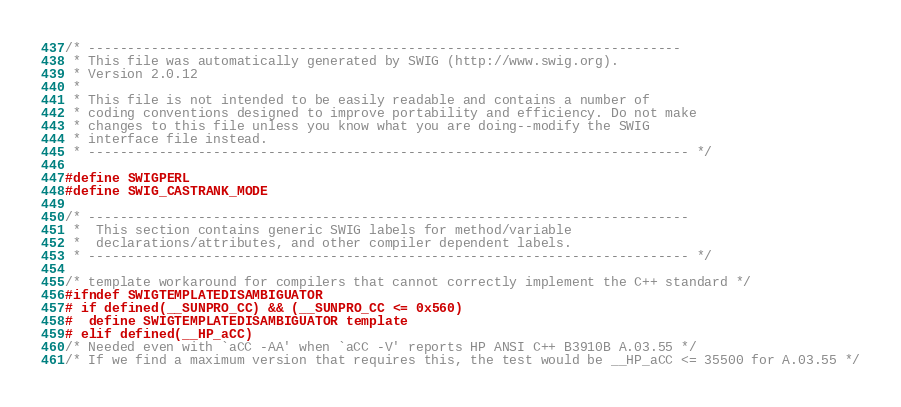<code> <loc_0><loc_0><loc_500><loc_500><_C_>/* ----------------------------------------------------------------------------
 * This file was automatically generated by SWIG (http://www.swig.org).
 * Version 2.0.12
 *
 * This file is not intended to be easily readable and contains a number of
 * coding conventions designed to improve portability and efficiency. Do not make
 * changes to this file unless you know what you are doing--modify the SWIG
 * interface file instead.
 * ----------------------------------------------------------------------------- */

#define SWIGPERL
#define SWIG_CASTRANK_MODE

/* -----------------------------------------------------------------------------
 *  This section contains generic SWIG labels for method/variable
 *  declarations/attributes, and other compiler dependent labels.
 * ----------------------------------------------------------------------------- */

/* template workaround for compilers that cannot correctly implement the C++ standard */
#ifndef SWIGTEMPLATEDISAMBIGUATOR
# if defined(__SUNPRO_CC) && (__SUNPRO_CC <= 0x560)
#  define SWIGTEMPLATEDISAMBIGUATOR template
# elif defined(__HP_aCC)
/* Needed even with `aCC -AA' when `aCC -V' reports HP ANSI C++ B3910B A.03.55 */
/* If we find a maximum version that requires this, the test would be __HP_aCC <= 35500 for A.03.55 */</code> 